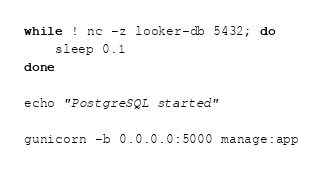<code> <loc_0><loc_0><loc_500><loc_500><_Bash_>while ! nc -z looker-db 5432; do
    sleep 0.1
done

echo "PostgreSQL started"

gunicorn -b 0.0.0.0:5000 manage:app</code> 